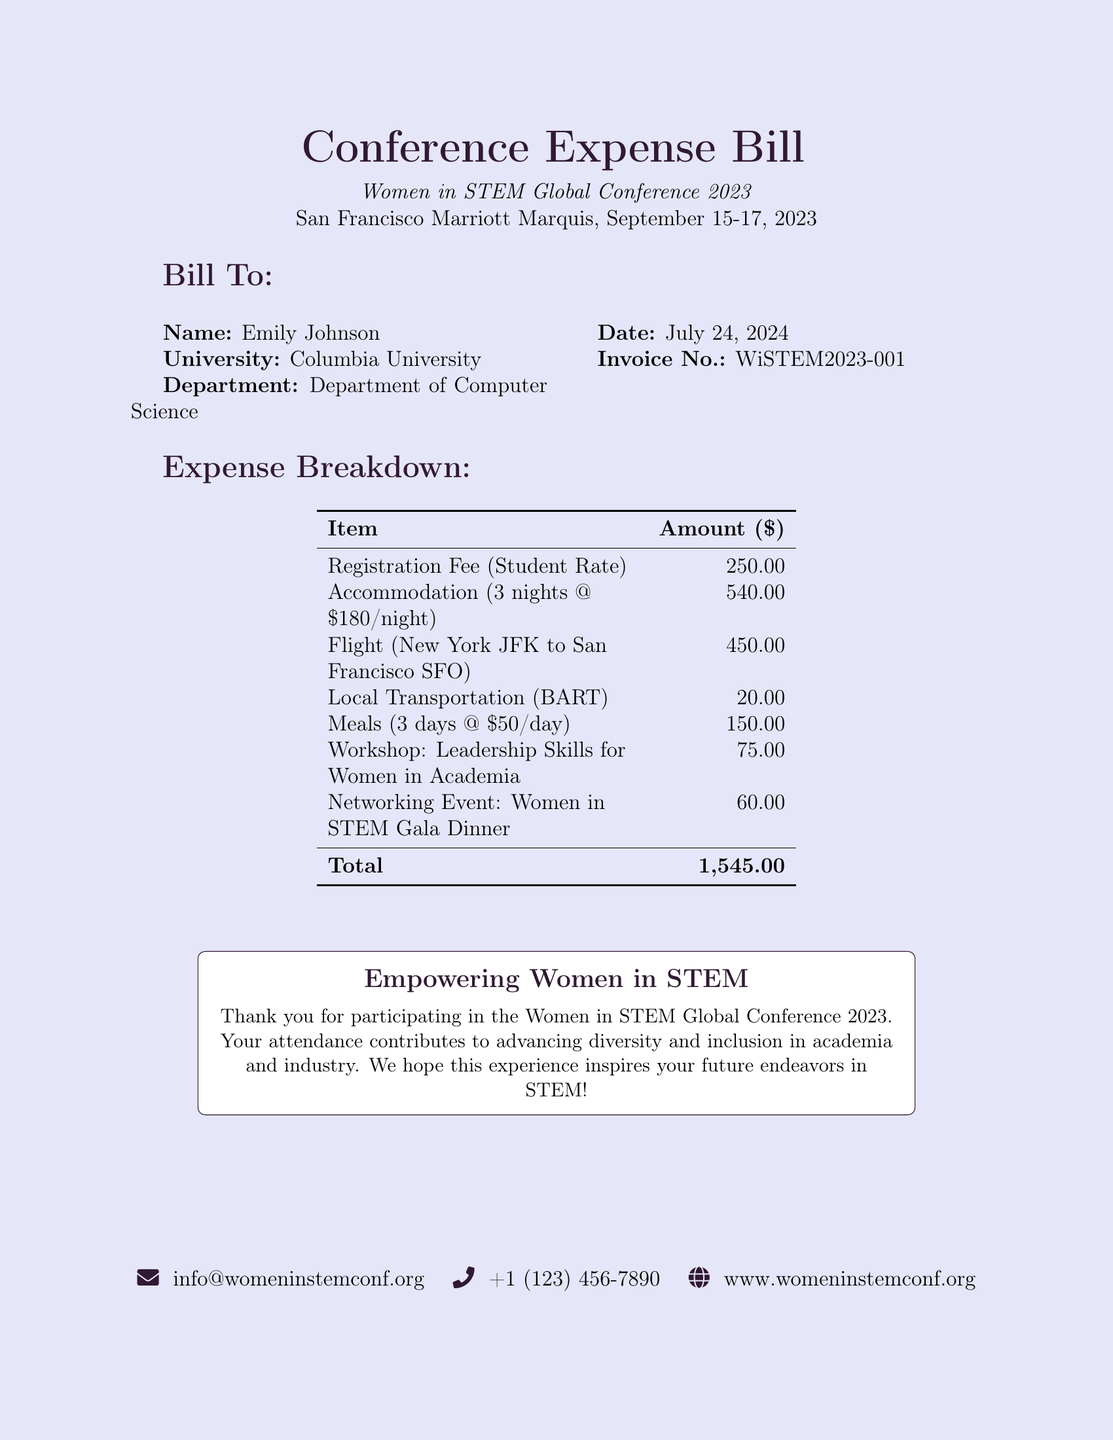What is the name of the recipient? The name of the recipient is listed under the "Bill To:" section.
Answer: Emily Johnson What is the date of the conference? The date of the conference is mentioned at the beginning of the document.
Answer: September 15-17, 2023 What is the total amount for the conference expenses? The total amount is calculated from the expense breakdown in the table.
Answer: 1,545.00 How much is the registration fee? The registration fee is provided in the expense breakdown.
Answer: 250.00 What city is the conference being held in? The location of the conference is specified at the start of the document.
Answer: San Francisco How many nights of accommodation are covered? The number of nights can be inferred from the accommodation expense line in the breakdown.
Answer: 3 nights How much is allocated for meals? The allocated amount for meals is summarized in the expense breakdown table.
Answer: 150.00 What workshop is included in the expenses? The workshop title is listed in the expense breakdown.
Answer: Leadership Skills for Women in Academia What is the invoice number? The invoice number is provided in the "Bill To:" section.
Answer: WiSTEM2023-001 